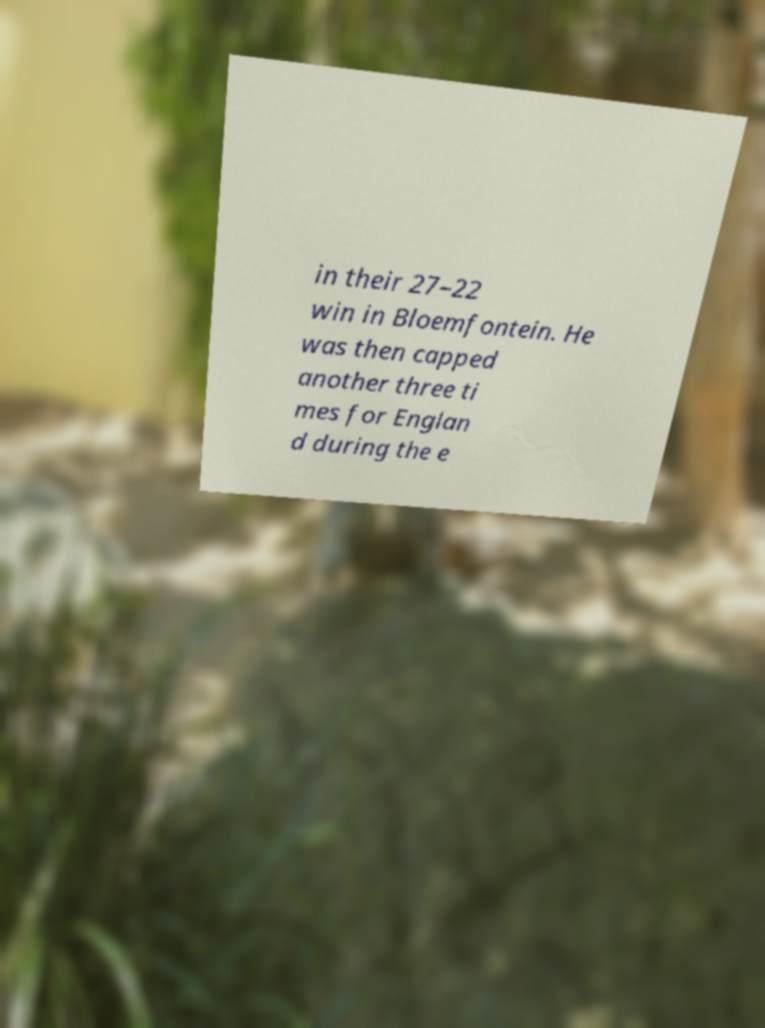Could you extract and type out the text from this image? in their 27–22 win in Bloemfontein. He was then capped another three ti mes for Englan d during the e 